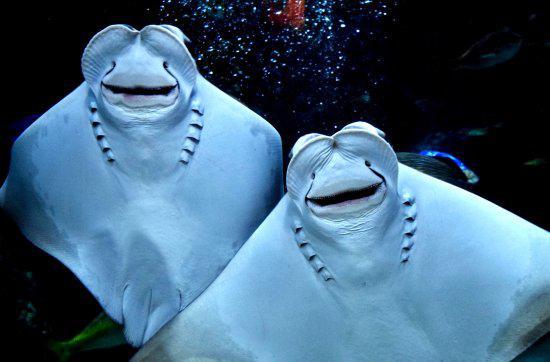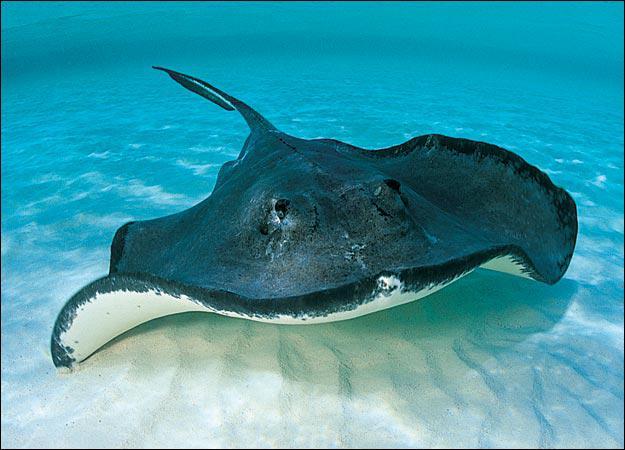The first image is the image on the left, the second image is the image on the right. Considering the images on both sides, is "No image contains more than two stingray, and one image shows the underside of at least one stingray, while the other image shows the top of at least one stingray." valid? Answer yes or no. Yes. The first image is the image on the left, the second image is the image on the right. Analyze the images presented: Is the assertion "The left and right image contains no more than three stingrays." valid? Answer yes or no. Yes. 